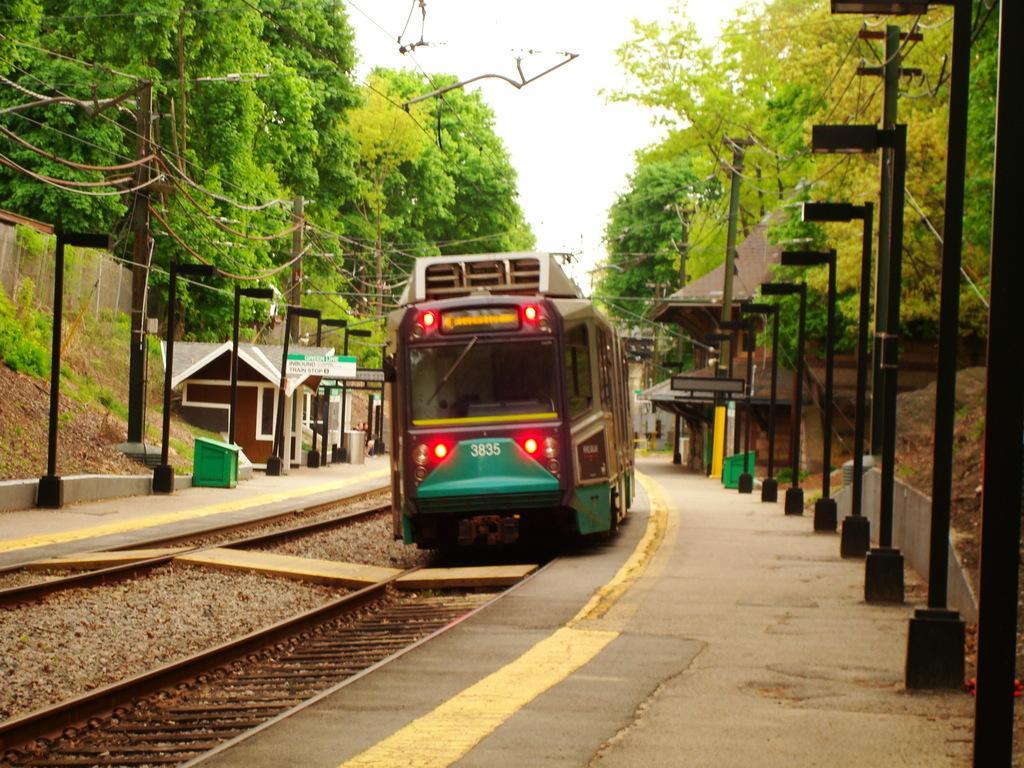In one or two sentences, can you explain what this image depicts? In this image, we can see a train in between poles. There are some trees in the top left and in the top right of the image. There is a sky at the top of the image. 